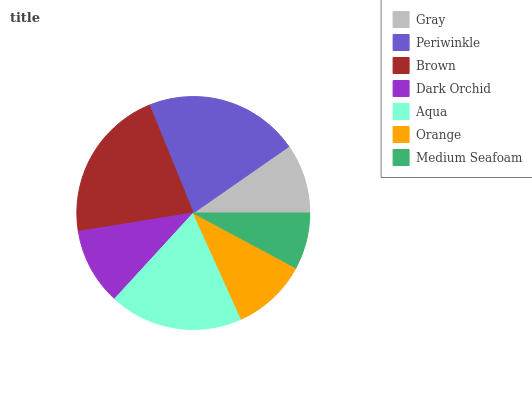Is Medium Seafoam the minimum?
Answer yes or no. Yes. Is Periwinkle the maximum?
Answer yes or no. Yes. Is Brown the minimum?
Answer yes or no. No. Is Brown the maximum?
Answer yes or no. No. Is Periwinkle greater than Brown?
Answer yes or no. Yes. Is Brown less than Periwinkle?
Answer yes or no. Yes. Is Brown greater than Periwinkle?
Answer yes or no. No. Is Periwinkle less than Brown?
Answer yes or no. No. Is Dark Orchid the high median?
Answer yes or no. Yes. Is Dark Orchid the low median?
Answer yes or no. Yes. Is Periwinkle the high median?
Answer yes or no. No. Is Medium Seafoam the low median?
Answer yes or no. No. 